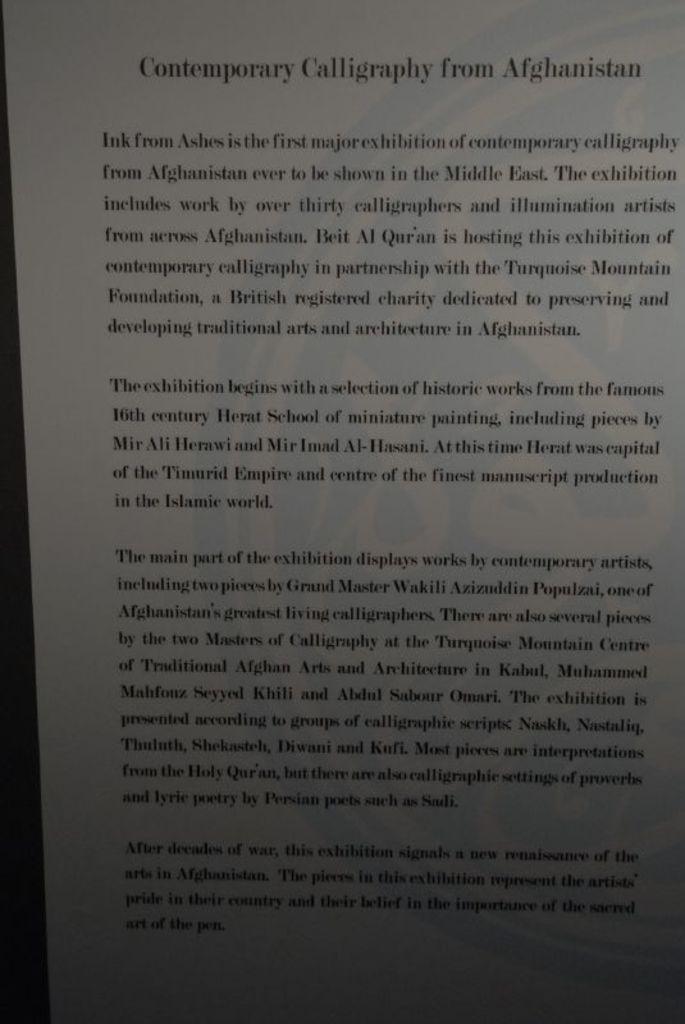What is the first word of the first paragraph?
Offer a very short reply. Ink. 